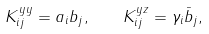Convert formula to latex. <formula><loc_0><loc_0><loc_500><loc_500>K _ { i j } ^ { y y } = a _ { i } b _ { j } , \quad K _ { i j } ^ { y z } = \gamma _ { i } \bar { b } _ { j } ,</formula> 